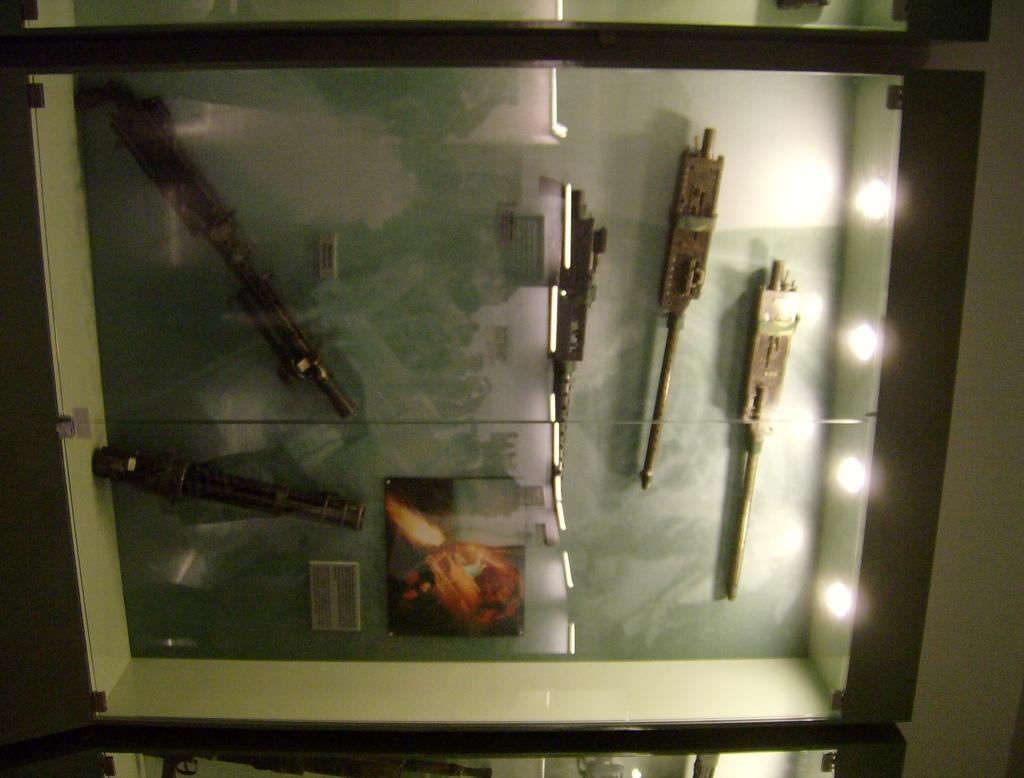What object can be seen in the image that is made of wood? There is a wooden box in the image. What is inside the wooden box? The wooden box contains equipment made from rods. Where are the lights located in the image? The lights are on the right side of the image. What is beside the lights in the image? There is a wall beside the lights. What type of coal is stored in the wooden box? There is no coal present in the image; the wooden box contains equipment made from rods. Can you see a skirt hanging on the wall beside the lights? There is no skirt present in the image; the wall beside the lights only has lights. 